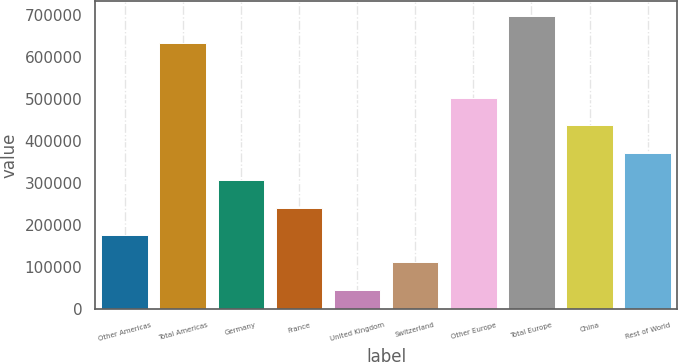Convert chart. <chart><loc_0><loc_0><loc_500><loc_500><bar_chart><fcel>Other Americas<fcel>Total Americas<fcel>Germany<fcel>France<fcel>United Kingdom<fcel>Switzerland<fcel>Other Europe<fcel>Total Europe<fcel>China<fcel>Rest of World<nl><fcel>175727<fcel>633329<fcel>306470<fcel>241098<fcel>44983<fcel>110355<fcel>502586<fcel>698701<fcel>437214<fcel>371842<nl></chart> 